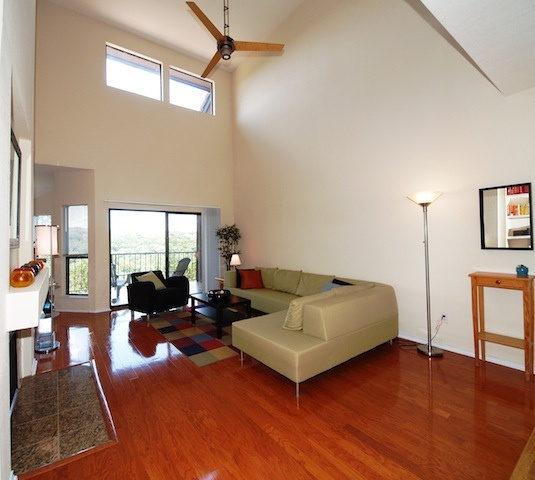Describe the objects in this image and their specific colors. I can see couch in white, olive, tan, and gray tones, chair in white, black, gray, and olive tones, potted plant in white, black, and gray tones, chair in white, gray, lightgray, and darkgray tones, and bowl in white, black, gray, darkgray, and maroon tones in this image. 